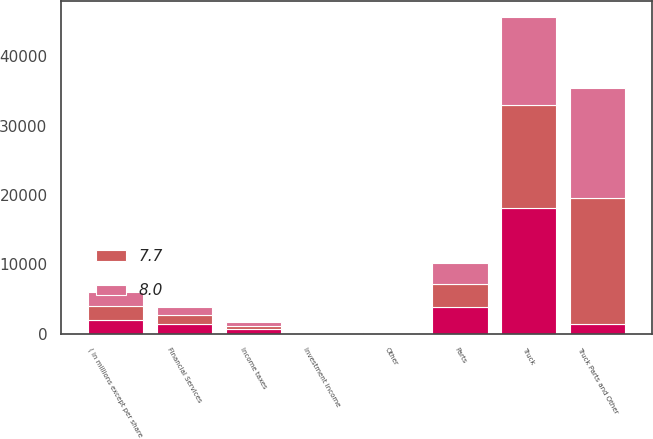Convert chart to OTSL. <chart><loc_0><loc_0><loc_500><loc_500><stacked_bar_chart><ecel><fcel>( in millions except per share<fcel>Truck<fcel>Parts<fcel>Other<fcel>Truck Parts and Other<fcel>Financial Services<fcel>Investment income<fcel>Income taxes<nl><fcel>nan<fcel>2018<fcel>18187<fcel>3838.9<fcel>112.7<fcel>1357.1<fcel>1357.1<fcel>60.9<fcel>615.1<nl><fcel>7.7<fcel>2017<fcel>14774.8<fcel>3327<fcel>85.7<fcel>18187.5<fcel>1268.9<fcel>35.3<fcel>498.1<nl><fcel>8<fcel>2016<fcel>12767.3<fcel>3005.7<fcel>73.6<fcel>15846.6<fcel>1186.7<fcel>27.6<fcel>608.7<nl></chart> 